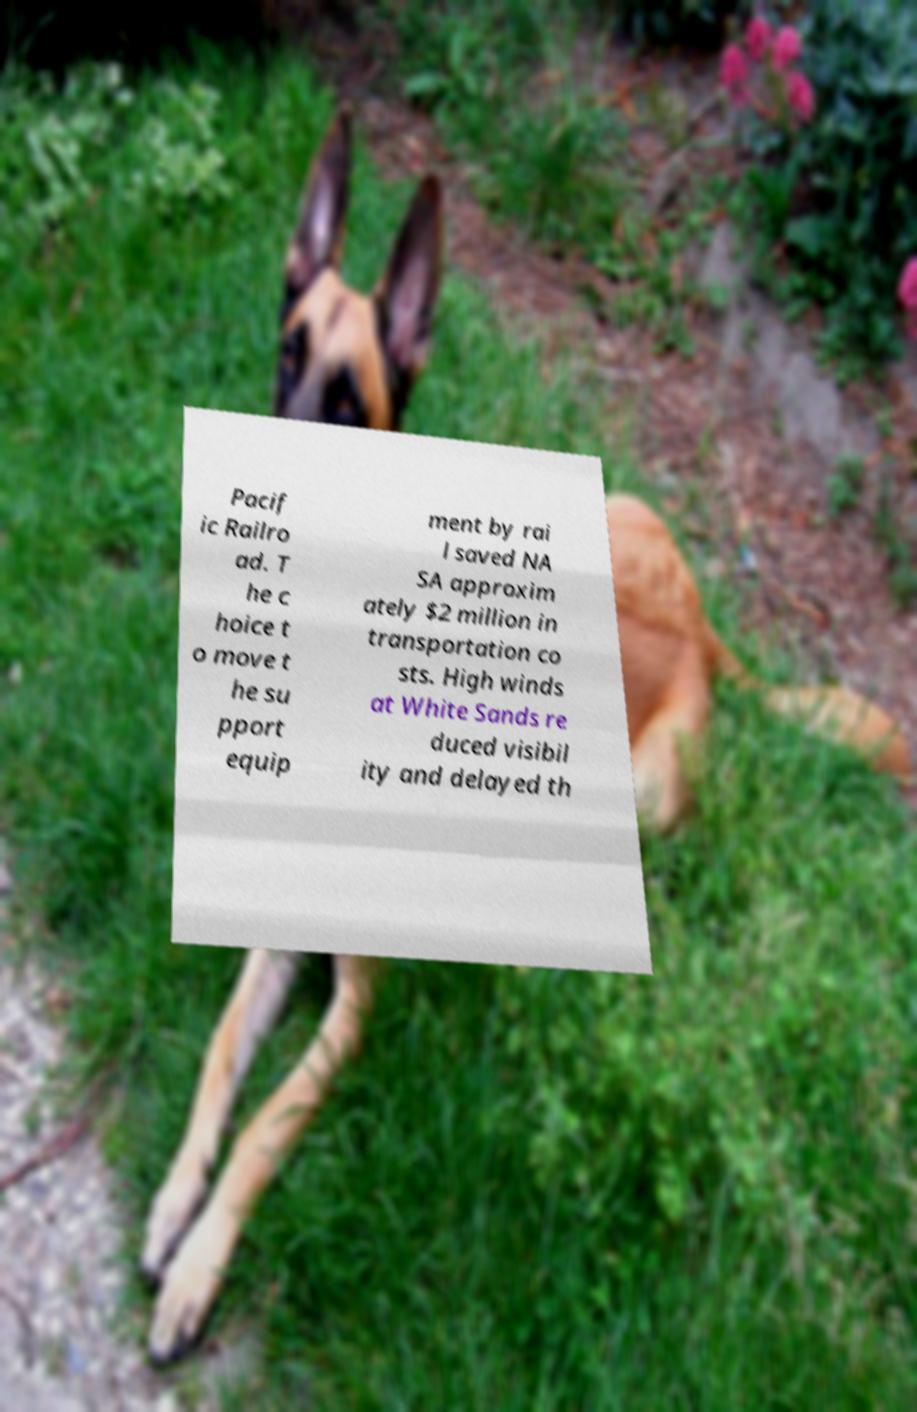What messages or text are displayed in this image? I need them in a readable, typed format. Pacif ic Railro ad. T he c hoice t o move t he su pport equip ment by rai l saved NA SA approxim ately $2 million in transportation co sts. High winds at White Sands re duced visibil ity and delayed th 